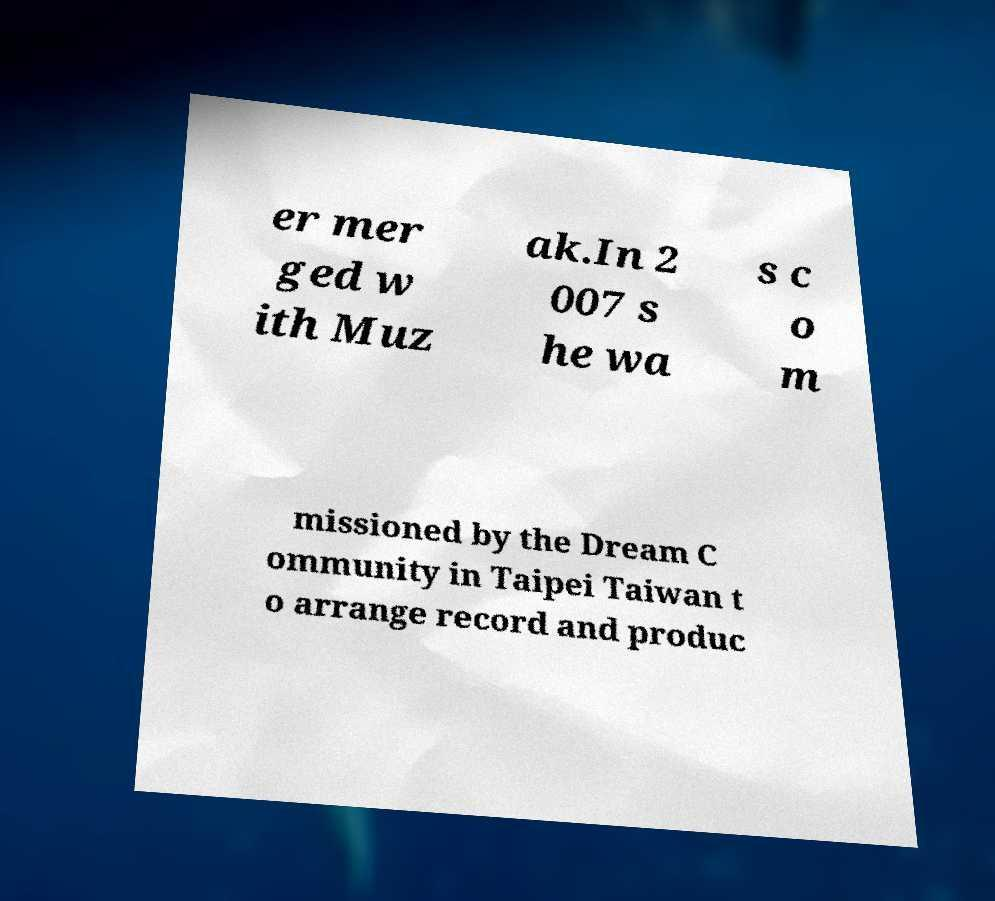There's text embedded in this image that I need extracted. Can you transcribe it verbatim? er mer ged w ith Muz ak.In 2 007 s he wa s c o m missioned by the Dream C ommunity in Taipei Taiwan t o arrange record and produc 